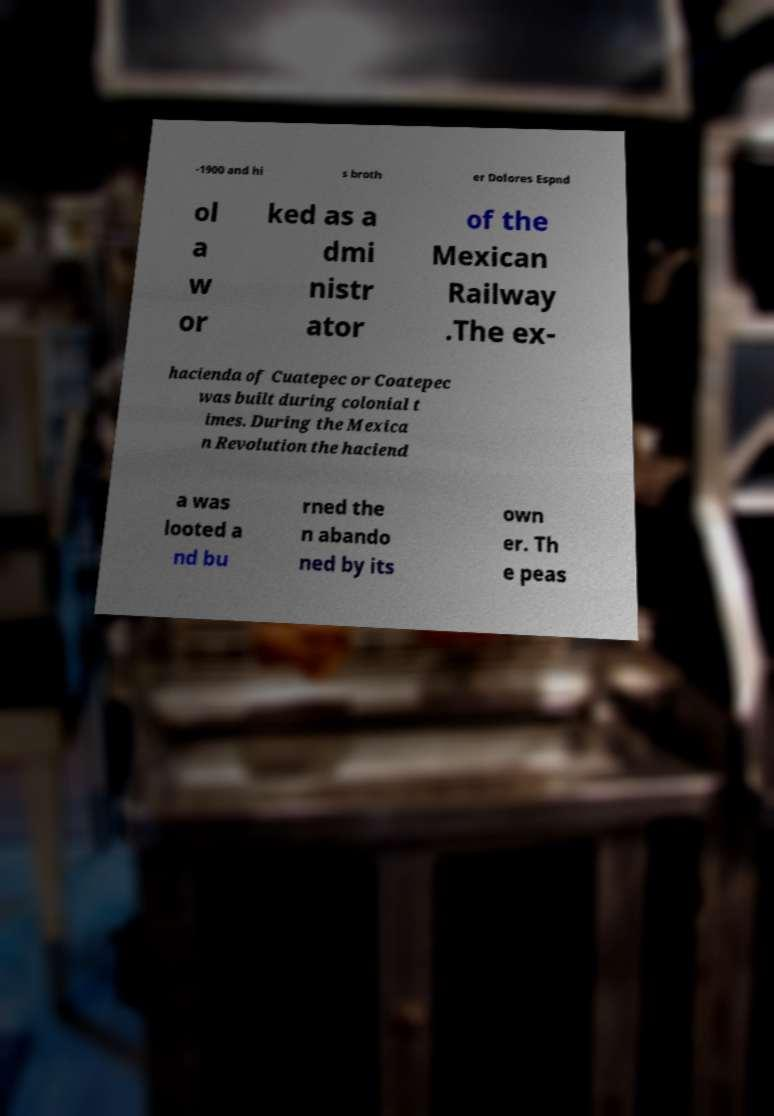I need the written content from this picture converted into text. Can you do that? -1900 and hi s broth er Dolores Espnd ol a w or ked as a dmi nistr ator of the Mexican Railway .The ex- hacienda of Cuatepec or Coatepec was built during colonial t imes. During the Mexica n Revolution the haciend a was looted a nd bu rned the n abando ned by its own er. Th e peas 